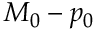<formula> <loc_0><loc_0><loc_500><loc_500>M _ { 0 } - p _ { 0 }</formula> 